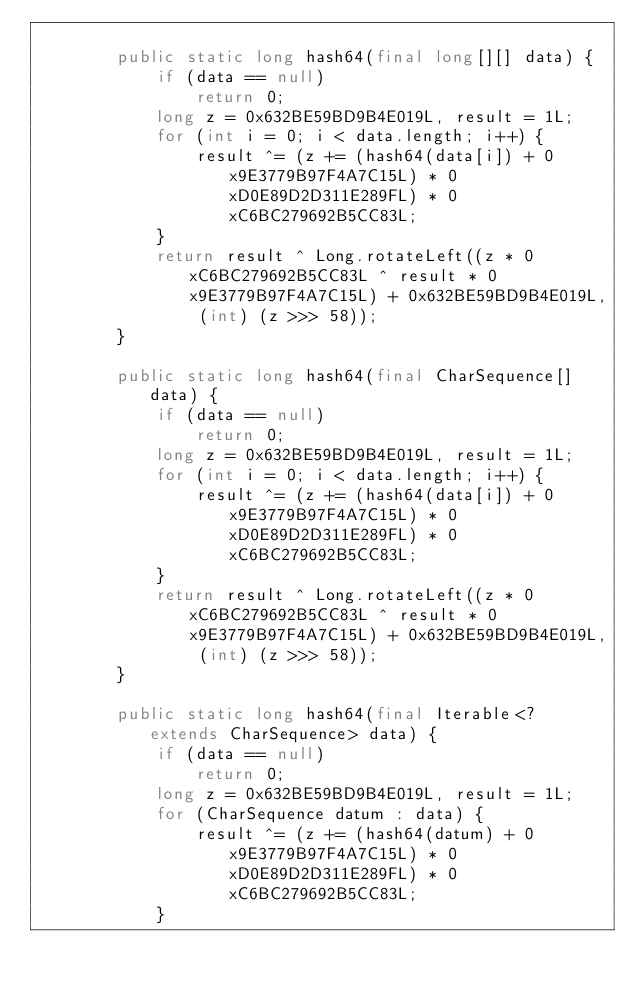Convert code to text. <code><loc_0><loc_0><loc_500><loc_500><_Java_>
        public static long hash64(final long[][] data) {
            if (data == null)
                return 0;
            long z = 0x632BE59BD9B4E019L, result = 1L;
            for (int i = 0; i < data.length; i++) {
                result ^= (z += (hash64(data[i]) + 0x9E3779B97F4A7C15L) * 0xD0E89D2D311E289FL) * 0xC6BC279692B5CC83L;
            }
            return result ^ Long.rotateLeft((z * 0xC6BC279692B5CC83L ^ result * 0x9E3779B97F4A7C15L) + 0x632BE59BD9B4E019L, (int) (z >>> 58));
        }

        public static long hash64(final CharSequence[] data) {
            if (data == null)
                return 0;
            long z = 0x632BE59BD9B4E019L, result = 1L;
            for (int i = 0; i < data.length; i++) {
                result ^= (z += (hash64(data[i]) + 0x9E3779B97F4A7C15L) * 0xD0E89D2D311E289FL) * 0xC6BC279692B5CC83L;
            }
            return result ^ Long.rotateLeft((z * 0xC6BC279692B5CC83L ^ result * 0x9E3779B97F4A7C15L) + 0x632BE59BD9B4E019L, (int) (z >>> 58));
        }

        public static long hash64(final Iterable<? extends CharSequence> data) {
            if (data == null)
                return 0;
            long z = 0x632BE59BD9B4E019L, result = 1L;
            for (CharSequence datum : data) {
                result ^= (z += (hash64(datum) + 0x9E3779B97F4A7C15L) * 0xD0E89D2D311E289FL) * 0xC6BC279692B5CC83L;
            }</code> 